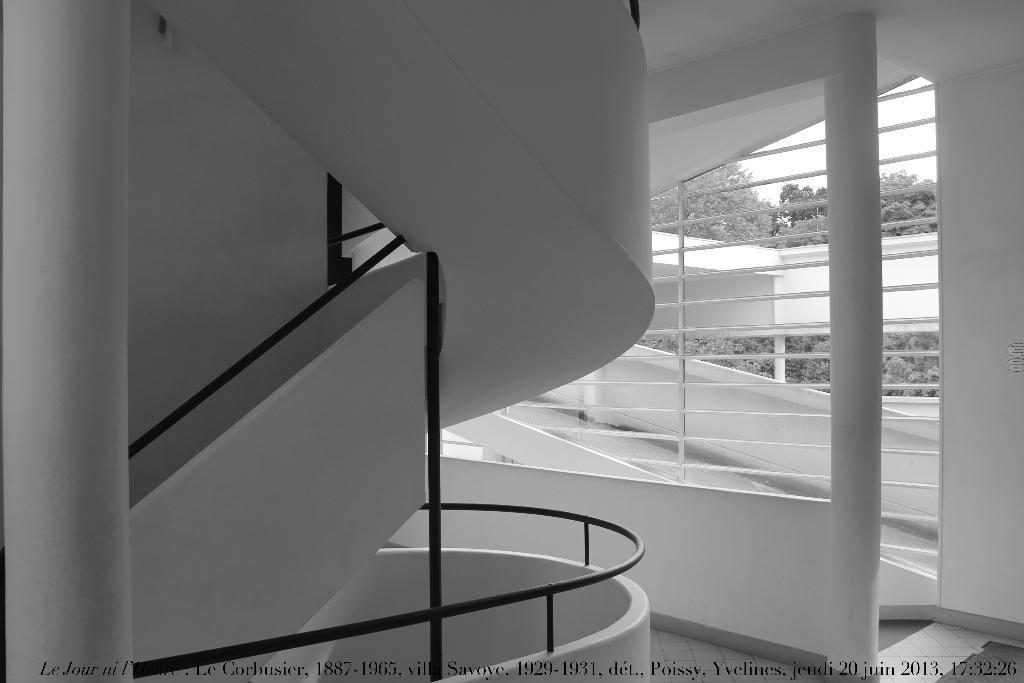In one or two sentences, can you explain what this image depicts? In this picture, we see the staircase and a stair railing. Behind that, we see a white wall and iron rods. In the background, we see the trees and a wall in white color. On the left side, we see a pillar in white color. At the bottom, we see some text written on it. It might be an edited image. 